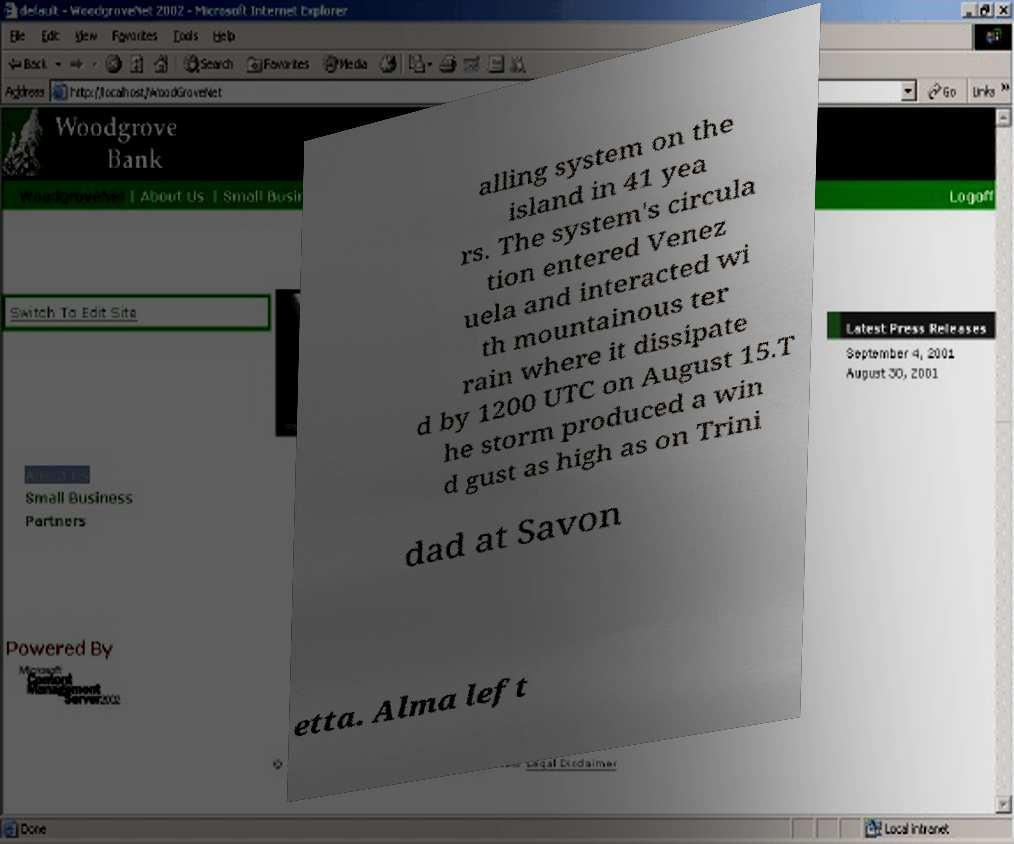Can you accurately transcribe the text from the provided image for me? alling system on the island in 41 yea rs. The system's circula tion entered Venez uela and interacted wi th mountainous ter rain where it dissipate d by 1200 UTC on August 15.T he storm produced a win d gust as high as on Trini dad at Savon etta. Alma left 